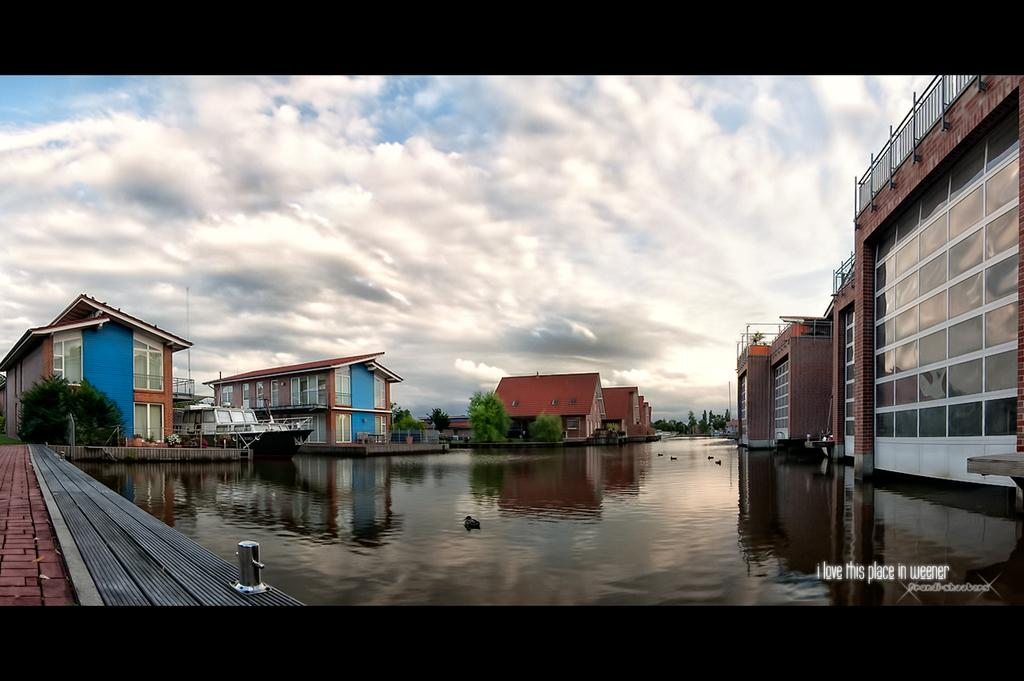What type of structures can be seen in the image? There are buildings in the image. What feature is present on the buildings? There are windows in the image. What type of vegetation is visible in the image? There are trees in the image. What natural element is visible in the image? There is water visible in the image. What is visible at the top of the image? The sky is visible at the top of the image. What can be seen in the sky? Clouds are present in the sky. Can you tell me how many babies are balancing on the brass railing in the image? There are no babies or brass railings present in the image. What type of brass object can be seen interacting with the clouds in the image? There is no brass object present in the image; only buildings, windows, trees, water, and clouds are visible. 